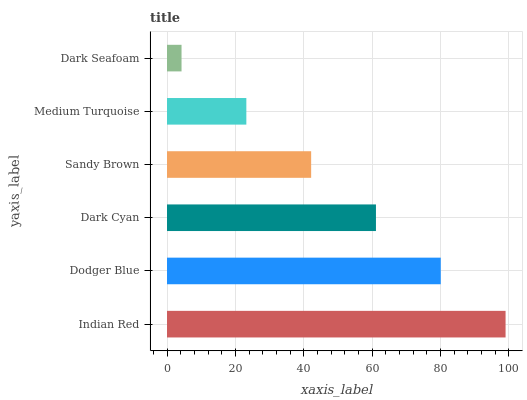Is Dark Seafoam the minimum?
Answer yes or no. Yes. Is Indian Red the maximum?
Answer yes or no. Yes. Is Dodger Blue the minimum?
Answer yes or no. No. Is Dodger Blue the maximum?
Answer yes or no. No. Is Indian Red greater than Dodger Blue?
Answer yes or no. Yes. Is Dodger Blue less than Indian Red?
Answer yes or no. Yes. Is Dodger Blue greater than Indian Red?
Answer yes or no. No. Is Indian Red less than Dodger Blue?
Answer yes or no. No. Is Dark Cyan the high median?
Answer yes or no. Yes. Is Sandy Brown the low median?
Answer yes or no. Yes. Is Sandy Brown the high median?
Answer yes or no. No. Is Medium Turquoise the low median?
Answer yes or no. No. 